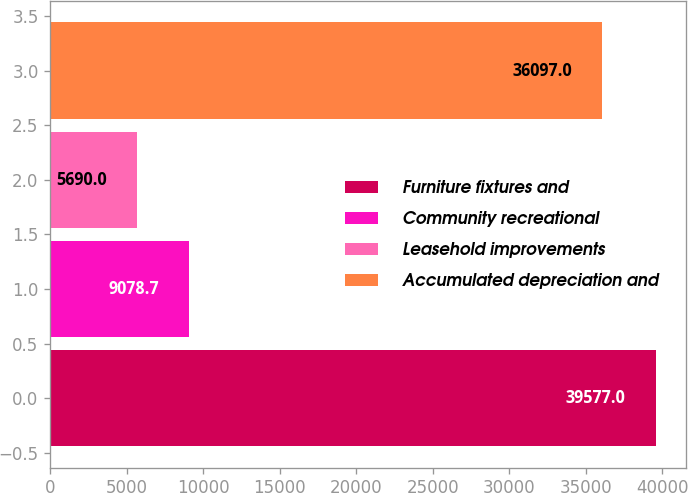<chart> <loc_0><loc_0><loc_500><loc_500><bar_chart><fcel>Furniture fixtures and<fcel>Community recreational<fcel>Leasehold improvements<fcel>Accumulated depreciation and<nl><fcel>39577<fcel>9078.7<fcel>5690<fcel>36097<nl></chart> 